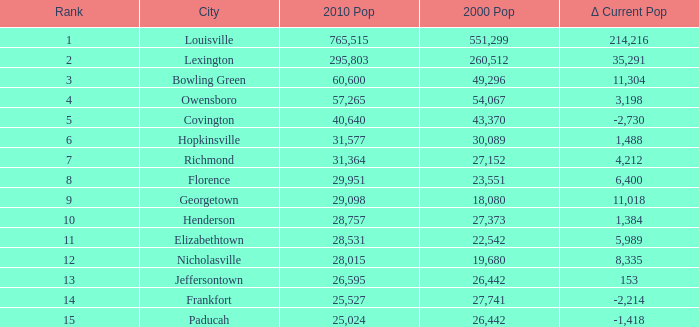What was the 2010 population of frankfort which has a rank smaller than 14? None. 